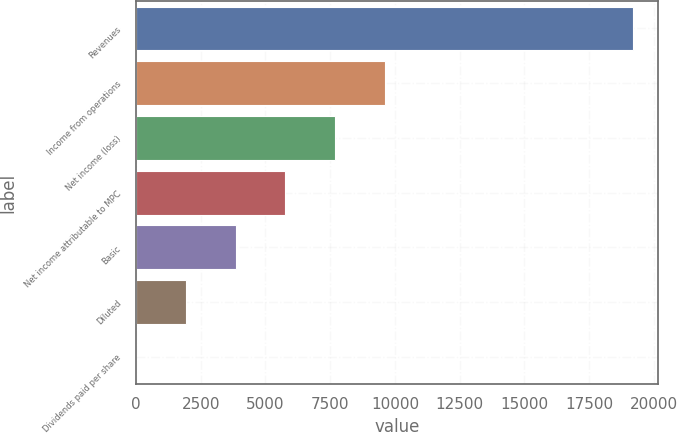<chart> <loc_0><loc_0><loc_500><loc_500><bar_chart><fcel>Revenues<fcel>Income from operations<fcel>Net income (loss)<fcel>Net income attributable to MPC<fcel>Basic<fcel>Diluted<fcel>Dividends paid per share<nl><fcel>19210<fcel>9605.2<fcel>7684.24<fcel>5763.28<fcel>3842.32<fcel>1921.36<fcel>0.4<nl></chart> 